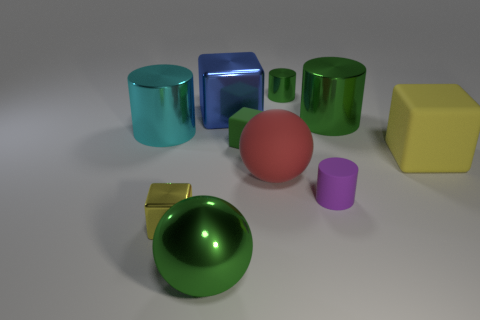Subtract 1 blocks. How many blocks are left? 3 Subtract all blocks. How many objects are left? 6 Add 7 tiny matte cubes. How many tiny matte cubes are left? 8 Add 9 small purple rubber blocks. How many small purple rubber blocks exist? 9 Subtract 0 cyan balls. How many objects are left? 10 Subtract all tiny yellow metal objects. Subtract all tiny blocks. How many objects are left? 7 